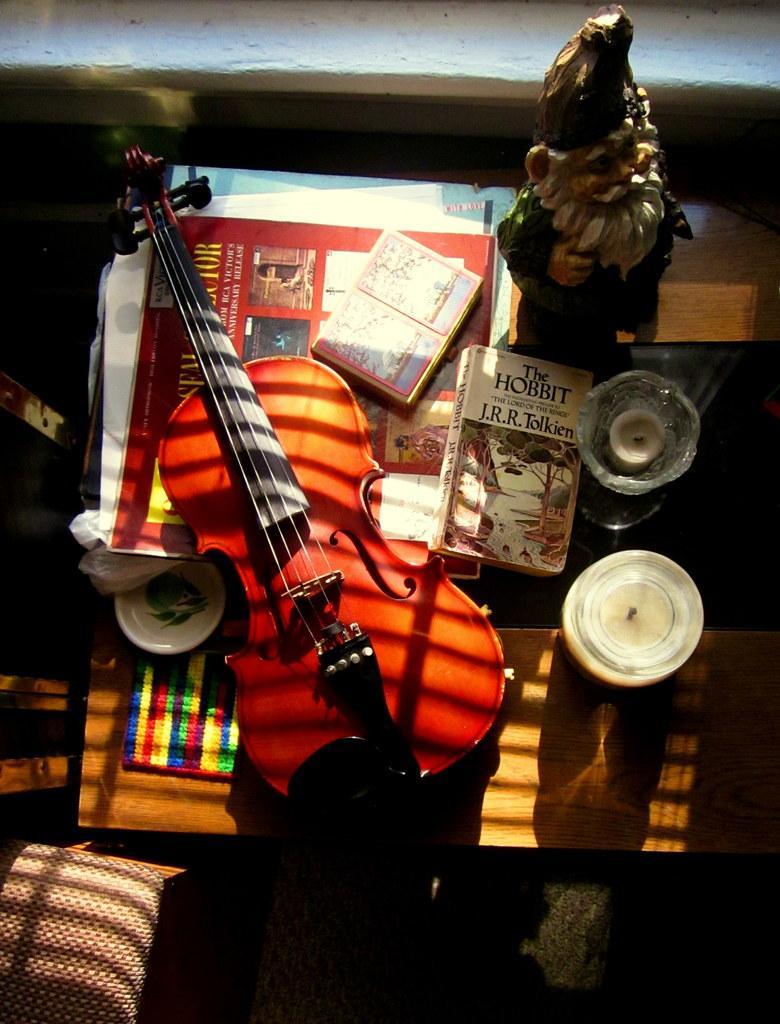In one or two sentences, can you explain what this image depicts? On a table there is guitar books santa claus statue and magazines on it. 